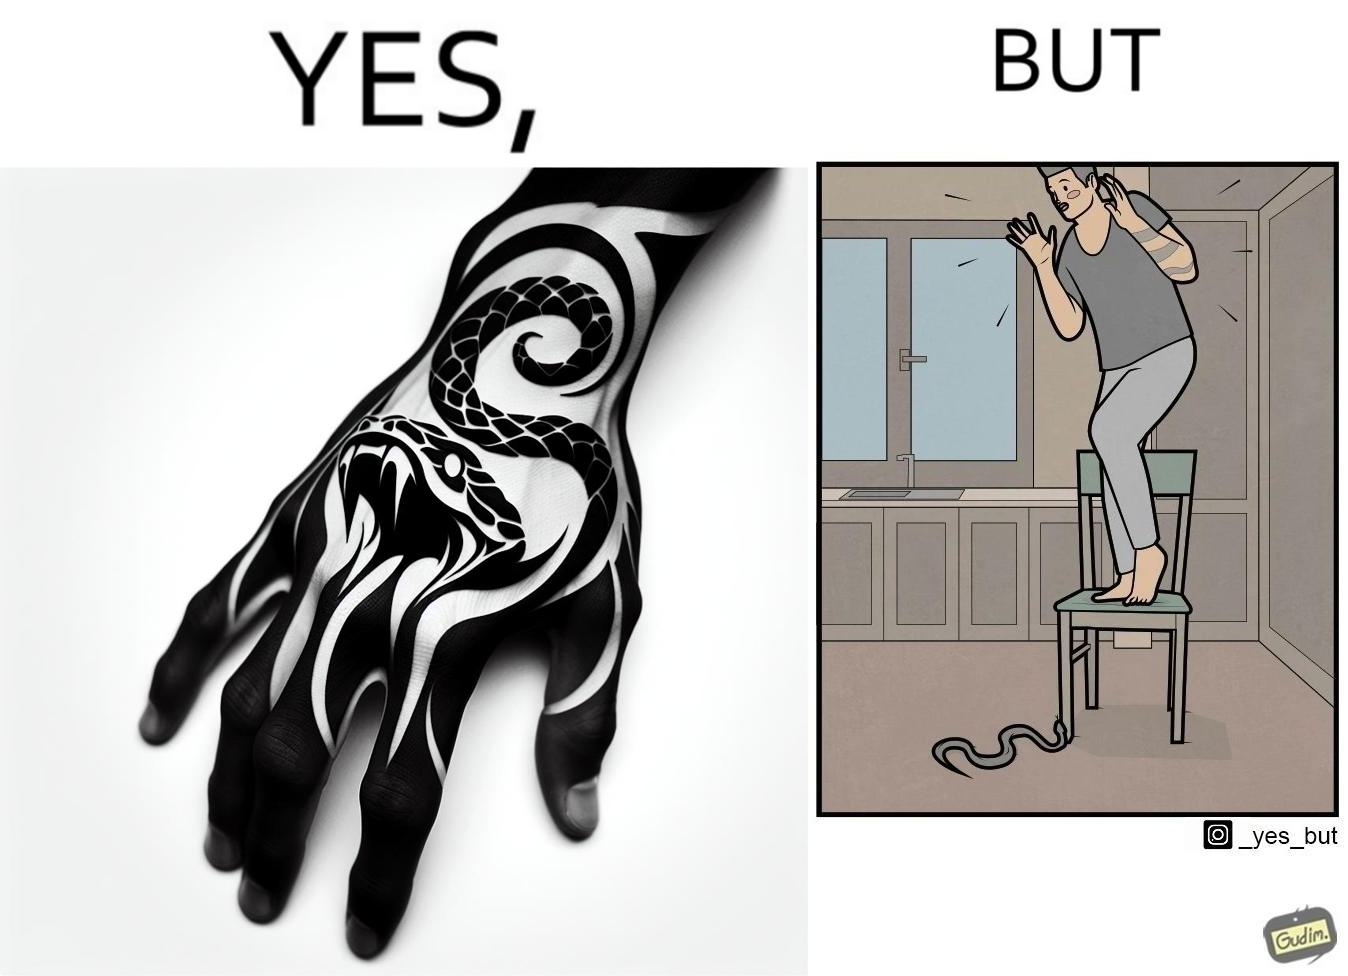Is this image satirical or non-satirical? Yes, this image is satirical. 